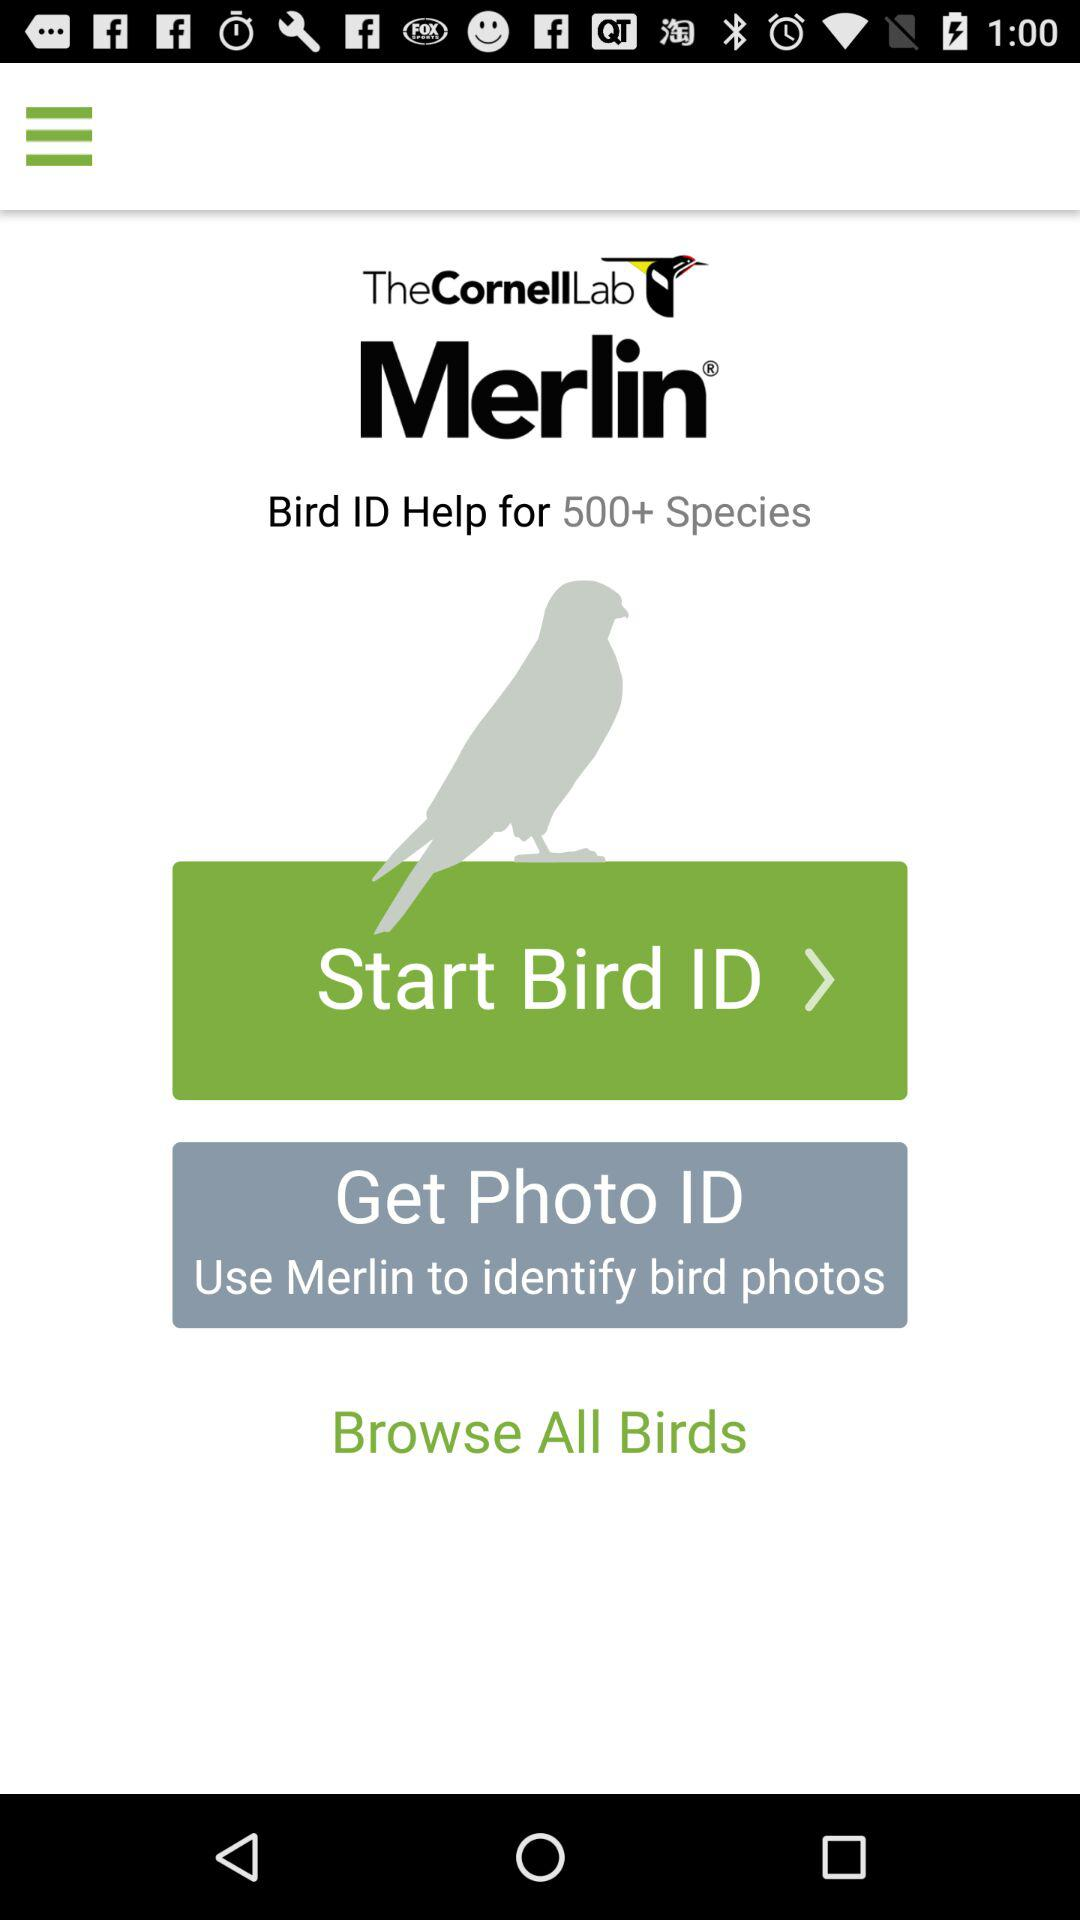What is the name of the application? The name of the application is "Merlin Bird ID". 